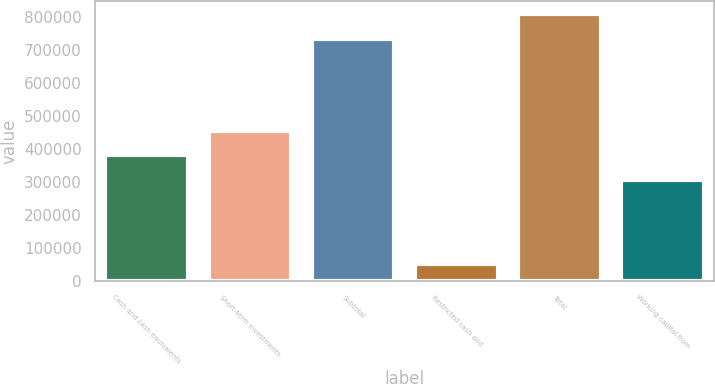Convert chart. <chart><loc_0><loc_0><loc_500><loc_500><bar_chart><fcel>Cash and cash equivalents<fcel>Short-term investments<fcel>Subtotal<fcel>Restricted cash and<fcel>Total<fcel>Working capital from<nl><fcel>381089<fcel>454651<fcel>735626<fcel>51518<fcel>809189<fcel>307526<nl></chart> 